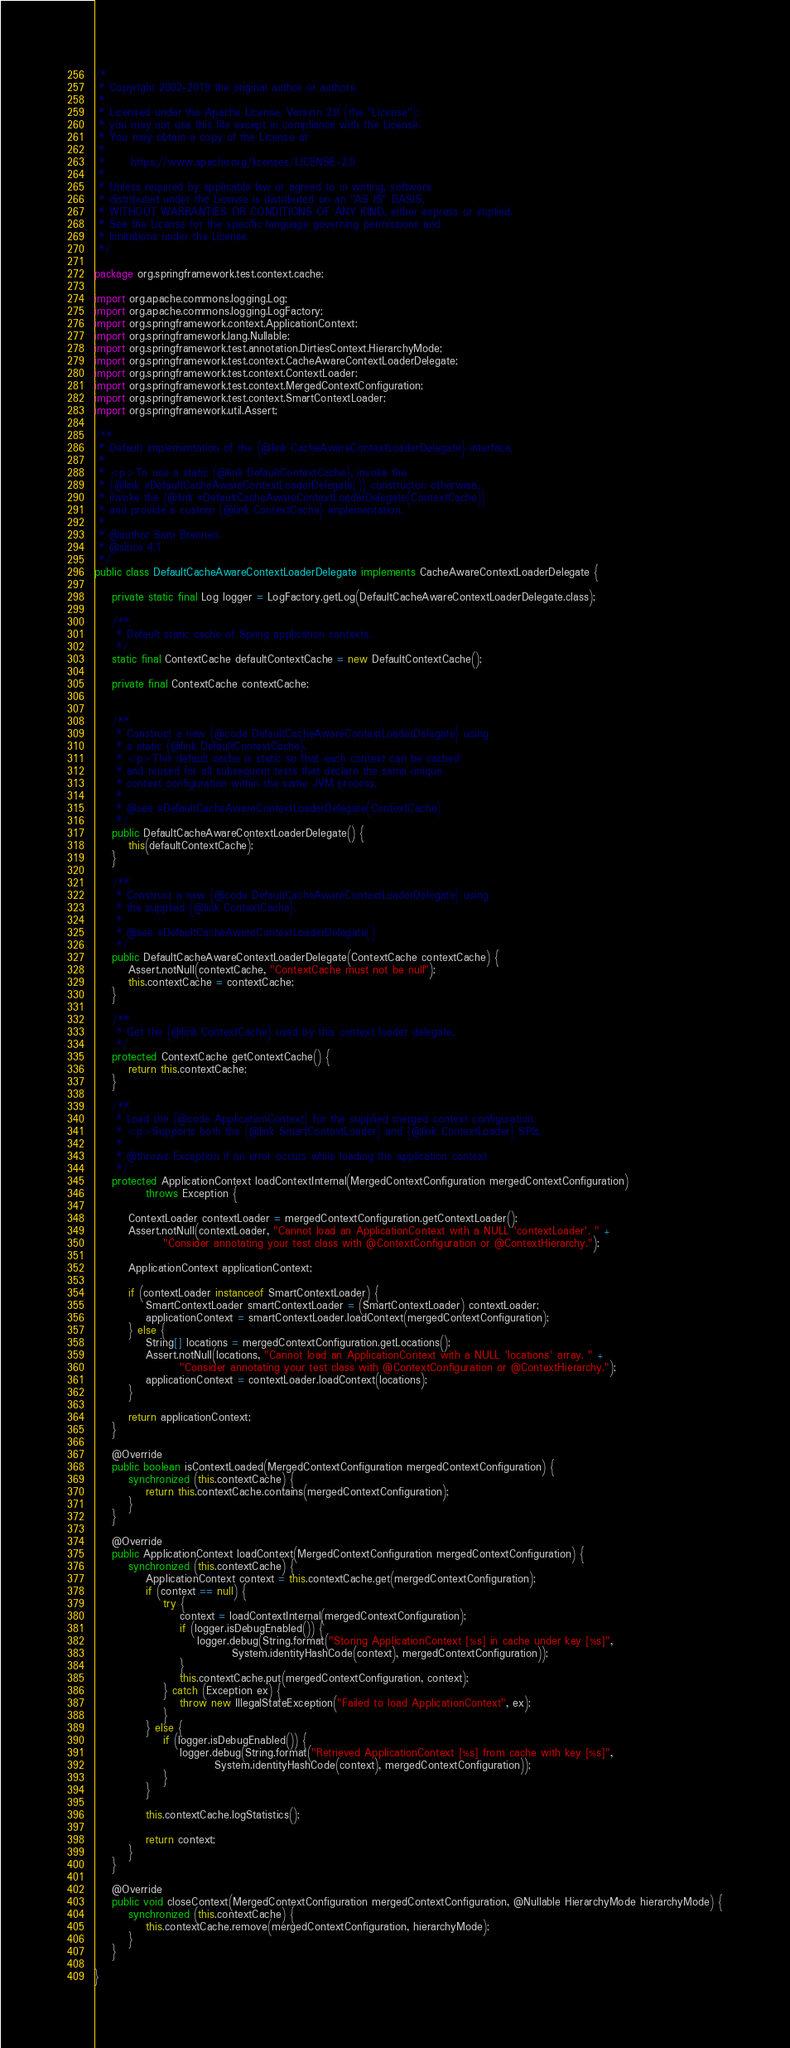<code> <loc_0><loc_0><loc_500><loc_500><_Java_>/*
 * Copyright 2002-2019 the original author or authors.
 *
 * Licensed under the Apache License, Version 2.0 (the "License");
 * you may not use this file except in compliance with the License.
 * You may obtain a copy of the License at
 *
 *      https://www.apache.org/licenses/LICENSE-2.0
 *
 * Unless required by applicable law or agreed to in writing, software
 * distributed under the License is distributed on an "AS IS" BASIS,
 * WITHOUT WARRANTIES OR CONDITIONS OF ANY KIND, either express or implied.
 * See the License for the specific language governing permissions and
 * limitations under the License.
 */

package org.springframework.test.context.cache;

import org.apache.commons.logging.Log;
import org.apache.commons.logging.LogFactory;
import org.springframework.context.ApplicationContext;
import org.springframework.lang.Nullable;
import org.springframework.test.annotation.DirtiesContext.HierarchyMode;
import org.springframework.test.context.CacheAwareContextLoaderDelegate;
import org.springframework.test.context.ContextLoader;
import org.springframework.test.context.MergedContextConfiguration;
import org.springframework.test.context.SmartContextLoader;
import org.springframework.util.Assert;

/**
 * Default implementation of the {@link CacheAwareContextLoaderDelegate} interface.
 *
 * <p>To use a static {@link DefaultContextCache}, invoke the
 * {@link #DefaultCacheAwareContextLoaderDelegate()} constructor; otherwise,
 * invoke the {@link #DefaultCacheAwareContextLoaderDelegate(ContextCache)}
 * and provide a custom {@link ContextCache} implementation.
 *
 * @author Sam Brannen
 * @since 4.1
 */
public class DefaultCacheAwareContextLoaderDelegate implements CacheAwareContextLoaderDelegate {

	private static final Log logger = LogFactory.getLog(DefaultCacheAwareContextLoaderDelegate.class);

	/**
	 * Default static cache of Spring application contexts.
	 */
	static final ContextCache defaultContextCache = new DefaultContextCache();

	private final ContextCache contextCache;


	/**
	 * Construct a new {@code DefaultCacheAwareContextLoaderDelegate} using
	 * a static {@link DefaultContextCache}.
	 * <p>This default cache is static so that each context can be cached
	 * and reused for all subsequent tests that declare the same unique
	 * context configuration within the same JVM process.
	 *
	 * @see #DefaultCacheAwareContextLoaderDelegate(ContextCache)
	 */
	public DefaultCacheAwareContextLoaderDelegate() {
		this(defaultContextCache);
	}

	/**
	 * Construct a new {@code DefaultCacheAwareContextLoaderDelegate} using
	 * the supplied {@link ContextCache}.
	 *
	 * @see #DefaultCacheAwareContextLoaderDelegate()
	 */
	public DefaultCacheAwareContextLoaderDelegate(ContextCache contextCache) {
		Assert.notNull(contextCache, "ContextCache must not be null");
		this.contextCache = contextCache;
	}

	/**
	 * Get the {@link ContextCache} used by this context loader delegate.
	 */
	protected ContextCache getContextCache() {
		return this.contextCache;
	}

	/**
	 * Load the {@code ApplicationContext} for the supplied merged context configuration.
	 * <p>Supports both the {@link SmartContextLoader} and {@link ContextLoader} SPIs.
	 *
	 * @throws Exception if an error occurs while loading the application context
	 */
	protected ApplicationContext loadContextInternal(MergedContextConfiguration mergedContextConfiguration)
			throws Exception {

		ContextLoader contextLoader = mergedContextConfiguration.getContextLoader();
		Assert.notNull(contextLoader, "Cannot load an ApplicationContext with a NULL 'contextLoader'. " +
				"Consider annotating your test class with @ContextConfiguration or @ContextHierarchy.");

		ApplicationContext applicationContext;

		if (contextLoader instanceof SmartContextLoader) {
			SmartContextLoader smartContextLoader = (SmartContextLoader) contextLoader;
			applicationContext = smartContextLoader.loadContext(mergedContextConfiguration);
		} else {
			String[] locations = mergedContextConfiguration.getLocations();
			Assert.notNull(locations, "Cannot load an ApplicationContext with a NULL 'locations' array. " +
					"Consider annotating your test class with @ContextConfiguration or @ContextHierarchy.");
			applicationContext = contextLoader.loadContext(locations);
		}

		return applicationContext;
	}

	@Override
	public boolean isContextLoaded(MergedContextConfiguration mergedContextConfiguration) {
		synchronized (this.contextCache) {
			return this.contextCache.contains(mergedContextConfiguration);
		}
	}

	@Override
	public ApplicationContext loadContext(MergedContextConfiguration mergedContextConfiguration) {
		synchronized (this.contextCache) {
			ApplicationContext context = this.contextCache.get(mergedContextConfiguration);
			if (context == null) {
				try {
					context = loadContextInternal(mergedContextConfiguration);
					if (logger.isDebugEnabled()) {
						logger.debug(String.format("Storing ApplicationContext [%s] in cache under key [%s]",
								System.identityHashCode(context), mergedContextConfiguration));
					}
					this.contextCache.put(mergedContextConfiguration, context);
				} catch (Exception ex) {
					throw new IllegalStateException("Failed to load ApplicationContext", ex);
				}
			} else {
				if (logger.isDebugEnabled()) {
					logger.debug(String.format("Retrieved ApplicationContext [%s] from cache with key [%s]",
							System.identityHashCode(context), mergedContextConfiguration));
				}
			}

			this.contextCache.logStatistics();

			return context;
		}
	}

	@Override
	public void closeContext(MergedContextConfiguration mergedContextConfiguration, @Nullable HierarchyMode hierarchyMode) {
		synchronized (this.contextCache) {
			this.contextCache.remove(mergedContextConfiguration, hierarchyMode);
		}
	}

}
</code> 